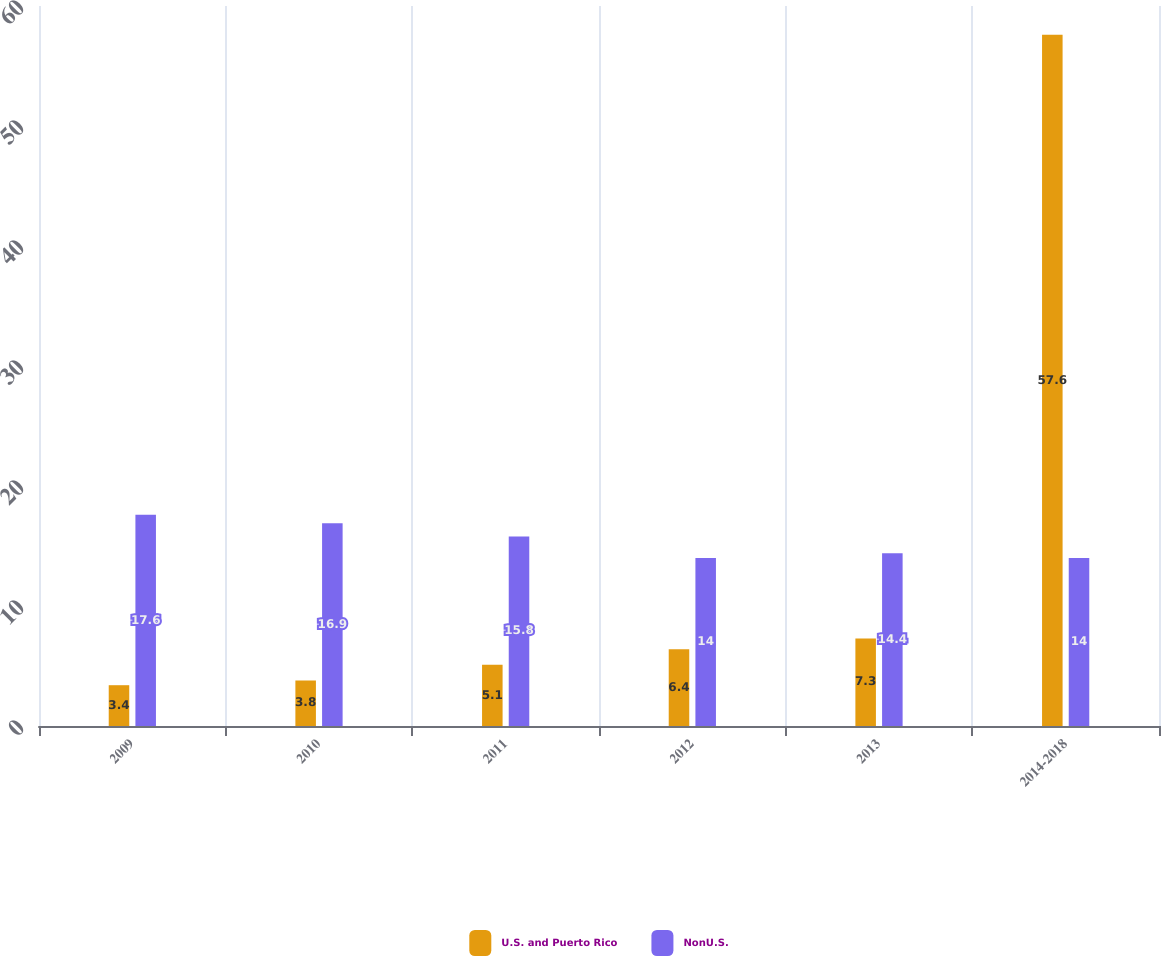Convert chart to OTSL. <chart><loc_0><loc_0><loc_500><loc_500><stacked_bar_chart><ecel><fcel>2009<fcel>2010<fcel>2011<fcel>2012<fcel>2013<fcel>2014-2018<nl><fcel>U.S. and Puerto Rico<fcel>3.4<fcel>3.8<fcel>5.1<fcel>6.4<fcel>7.3<fcel>57.6<nl><fcel>NonU.S.<fcel>17.6<fcel>16.9<fcel>15.8<fcel>14<fcel>14.4<fcel>14<nl></chart> 